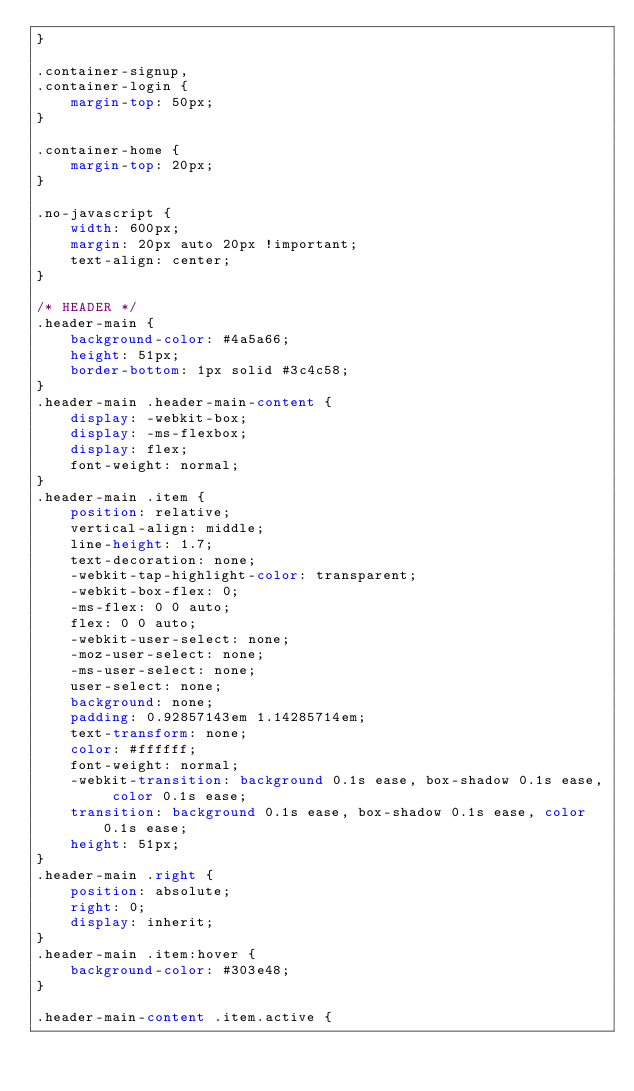<code> <loc_0><loc_0><loc_500><loc_500><_CSS_>}

.container-signup,
.container-login {
    margin-top: 50px;
}

.container-home {
    margin-top: 20px;
}

.no-javascript {
    width: 600px;
    margin: 20px auto 20px !important;
    text-align: center;
}

/* HEADER */
.header-main {
    background-color: #4a5a66;
    height: 51px;
    border-bottom: 1px solid #3c4c58;
}
.header-main .header-main-content {
    display: -webkit-box;
    display: -ms-flexbox;
    display: flex;
    font-weight: normal;
}
.header-main .item {
    position: relative;
    vertical-align: middle;
    line-height: 1.7;
    text-decoration: none;
    -webkit-tap-highlight-color: transparent;
    -webkit-box-flex: 0;
    -ms-flex: 0 0 auto;
    flex: 0 0 auto;
    -webkit-user-select: none;
    -moz-user-select: none;
    -ms-user-select: none;
    user-select: none;
    background: none;
    padding: 0.92857143em 1.14285714em;
    text-transform: none;
    color: #ffffff;
    font-weight: normal;
    -webkit-transition: background 0.1s ease, box-shadow 0.1s ease, color 0.1s ease;
    transition: background 0.1s ease, box-shadow 0.1s ease, color 0.1s ease;
    height: 51px;
}
.header-main .right {
    position: absolute;
    right: 0;
    display: inherit;
}
.header-main .item:hover {
    background-color: #303e48;
}

.header-main-content .item.active {</code> 